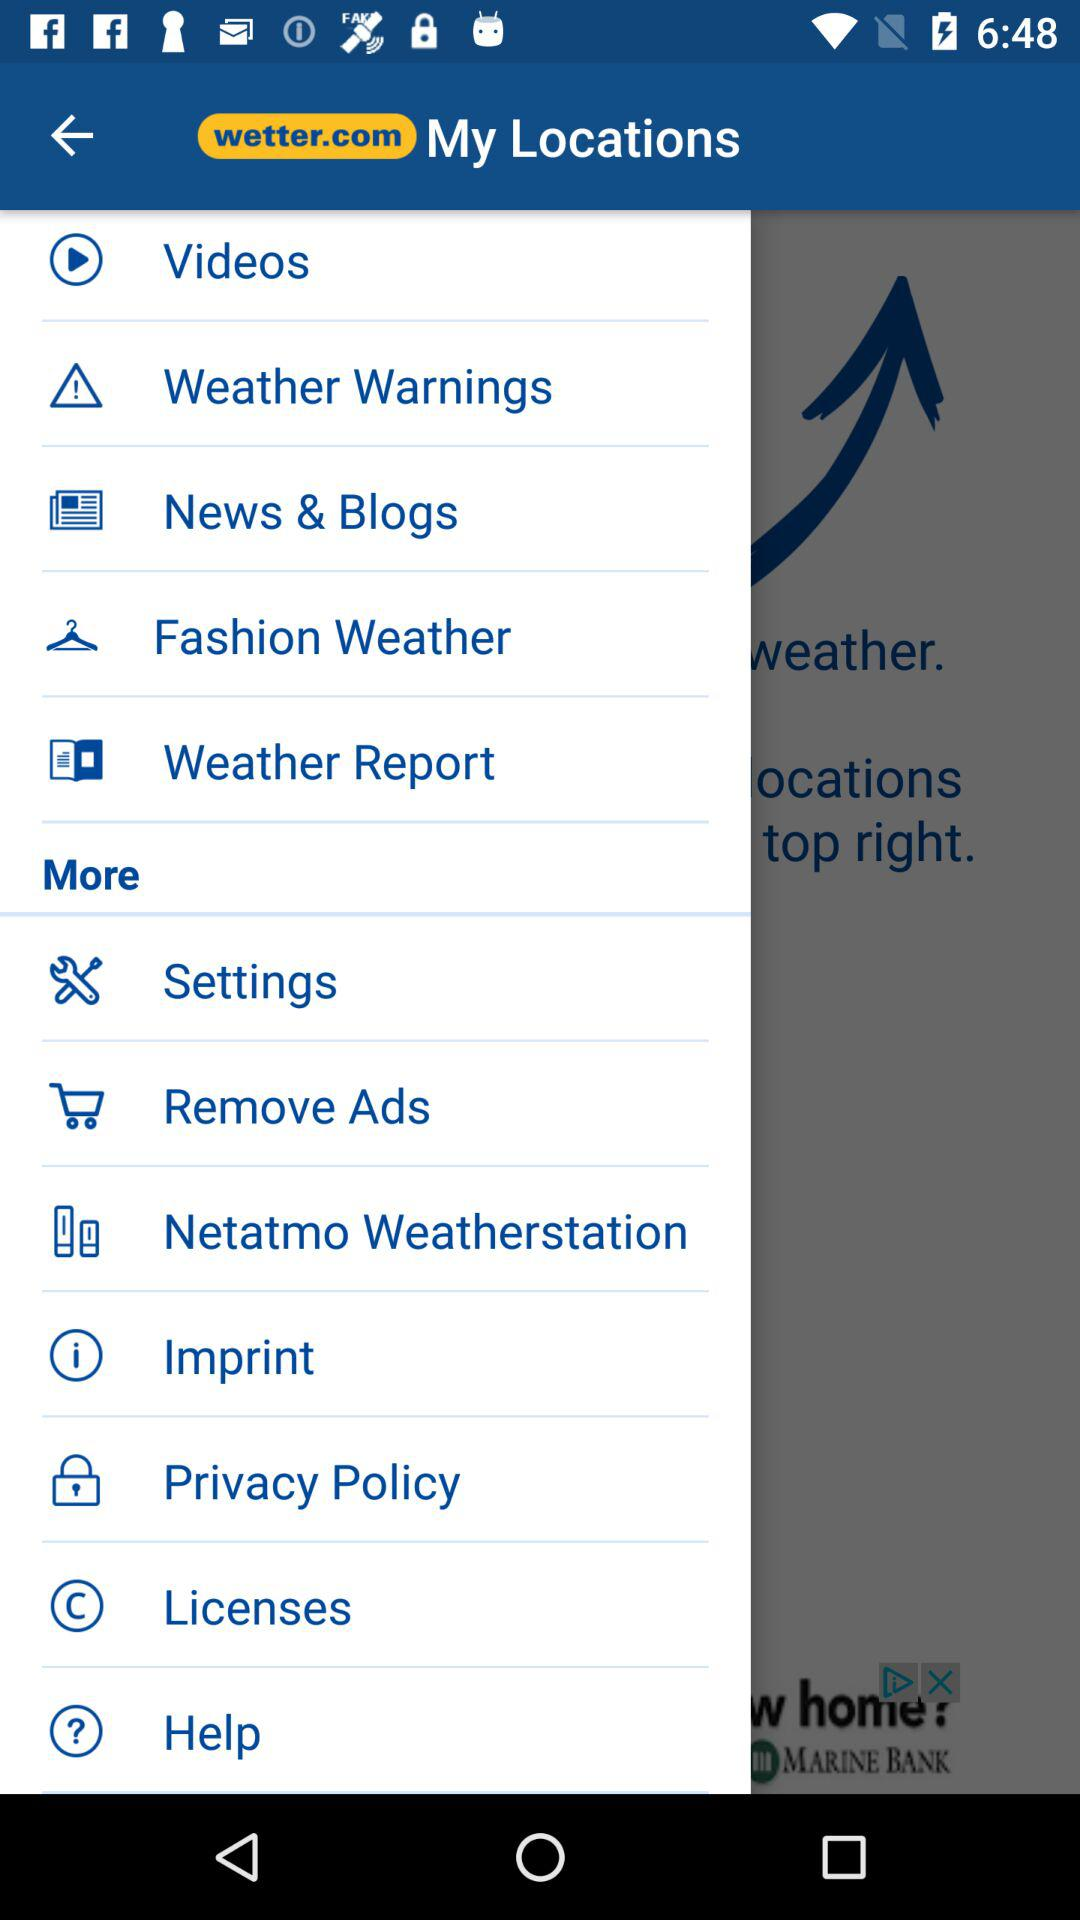What is the name of the application? The name of the application is "wetter.com". 